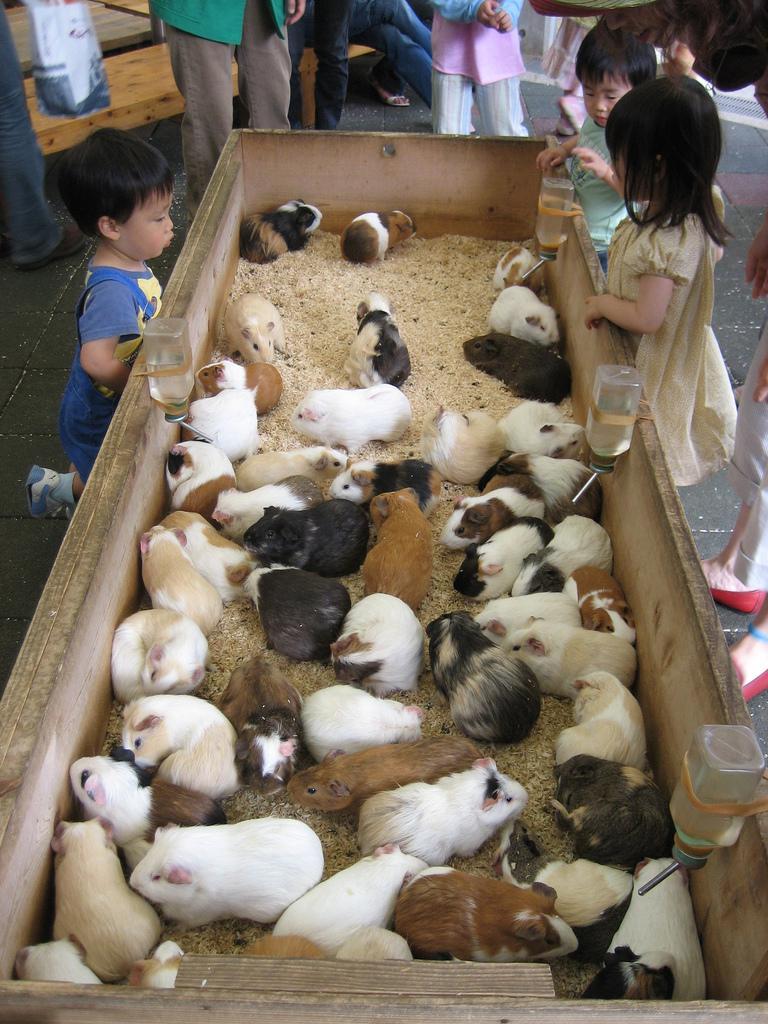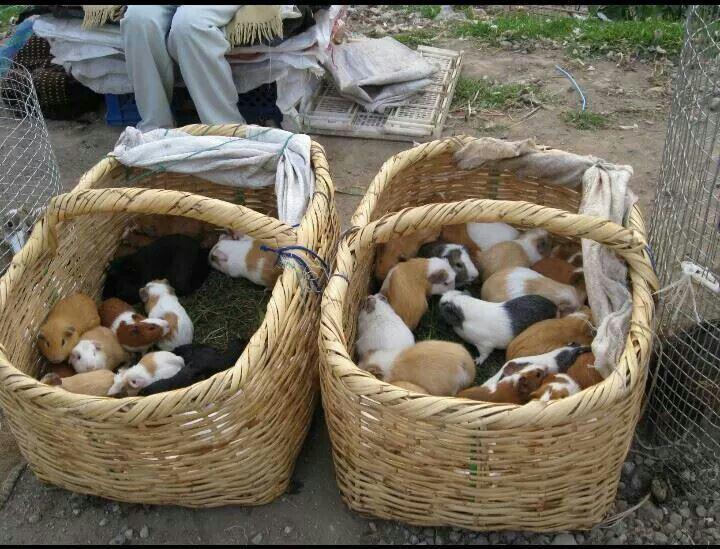The first image is the image on the left, the second image is the image on the right. Assess this claim about the two images: "An image shows variously colored hamsters arranged in stepped rows.". Correct or not? Answer yes or no. No. The first image is the image on the left, the second image is the image on the right. Evaluate the accuracy of this statement regarding the images: "Some of the animals are sitting on steps outside.". Is it true? Answer yes or no. No. 